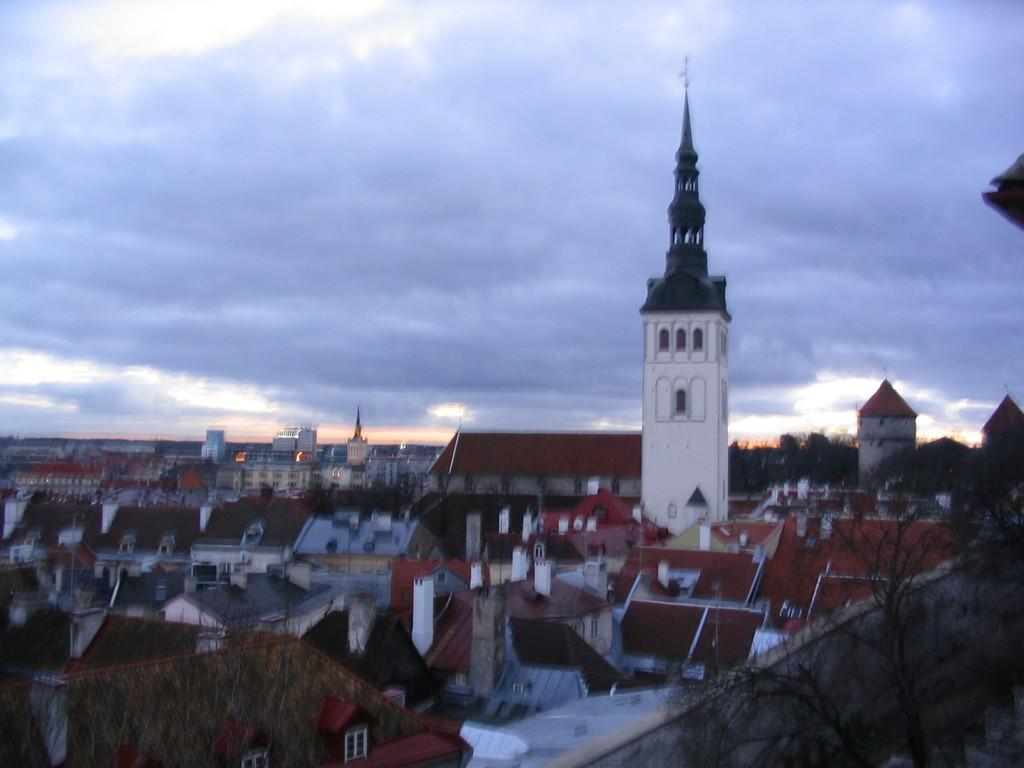What types of structures are located at the bottom of the image? There are houses and buildings at the bottom of the image. What else can be seen at the bottom of the image? There are trees at the bottom of the image. What is visible at the top of the image? The sky is visible at the top of the image. How would you describe the sky in the image? The sky is cloudy in the image. Can you tell me how many spies are hiding in the trees in the image? There are no spies present in the image; it only features houses, buildings, trees, and a cloudy sky. What color is the group of people standing near the houses in the image? There is no group of people present in the image, so we cannot determine their color. 